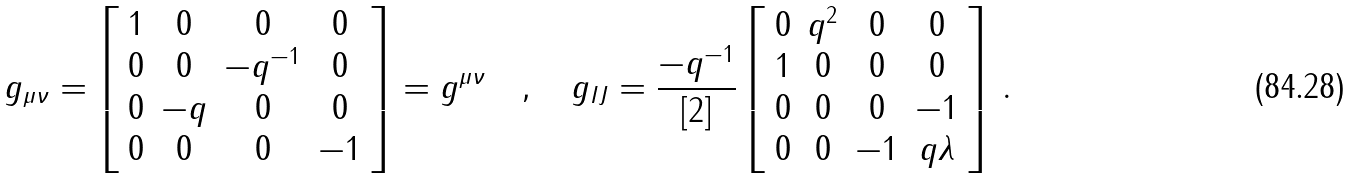Convert formula to latex. <formula><loc_0><loc_0><loc_500><loc_500>g _ { \mu \nu } = \left [ \begin{array} { c c c c } 1 & 0 & 0 & 0 \\ 0 & 0 & - q ^ { - 1 } & 0 \\ 0 & - q & 0 & 0 \\ 0 & 0 & 0 & - 1 \end{array} \right ] = g ^ { \mu \nu } \quad , \quad g _ { I J } = \frac { - q ^ { - 1 } } { \left [ 2 \right ] } \left [ \begin{array} { c c c c } 0 & q ^ { 2 } & 0 & 0 \\ 1 & 0 & 0 & 0 \\ 0 & 0 & 0 & - 1 \\ 0 & 0 & - 1 & q \lambda \end{array} \right ] \, .</formula> 